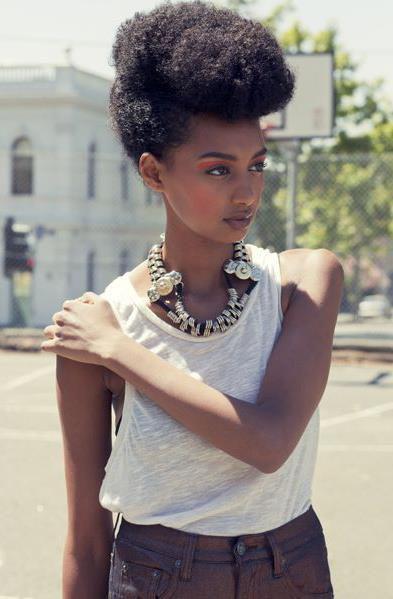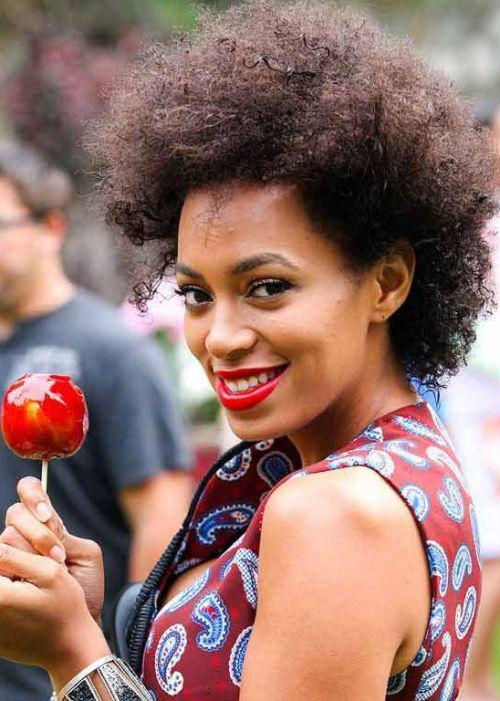The first image is the image on the left, the second image is the image on the right. Examine the images to the left and right. Is the description "The left image shows a leftward-facing male with no beard on his chin and a haircut that creates an unbroken right angle on the side." accurate? Answer yes or no. No. The first image is the image on the left, the second image is the image on the right. Given the left and right images, does the statement "The left and right image contains the same number of men with fades." hold true? Answer yes or no. No. 